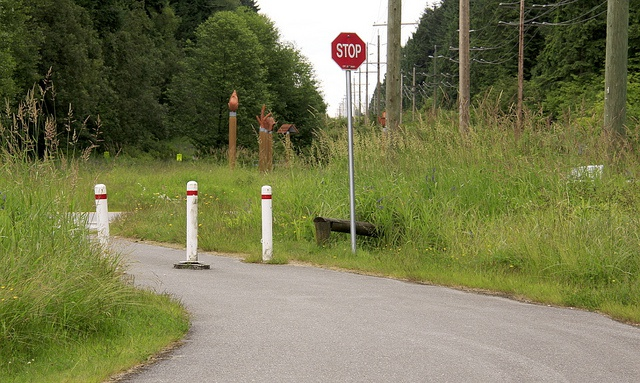Describe the objects in this image and their specific colors. I can see a stop sign in olive, brown, lightgray, and maroon tones in this image. 